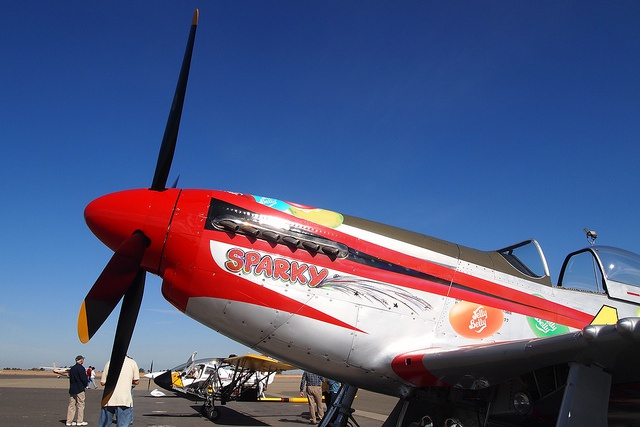Describe the objects in this image and their specific colors. I can see airplane in darkblue, black, white, red, and gray tones, airplane in darkblue, black, gray, white, and maroon tones, people in darkblue, ivory, gray, and black tones, people in darkblue, black, darkgray, and gray tones, and people in darkblue, gray, black, and tan tones in this image. 